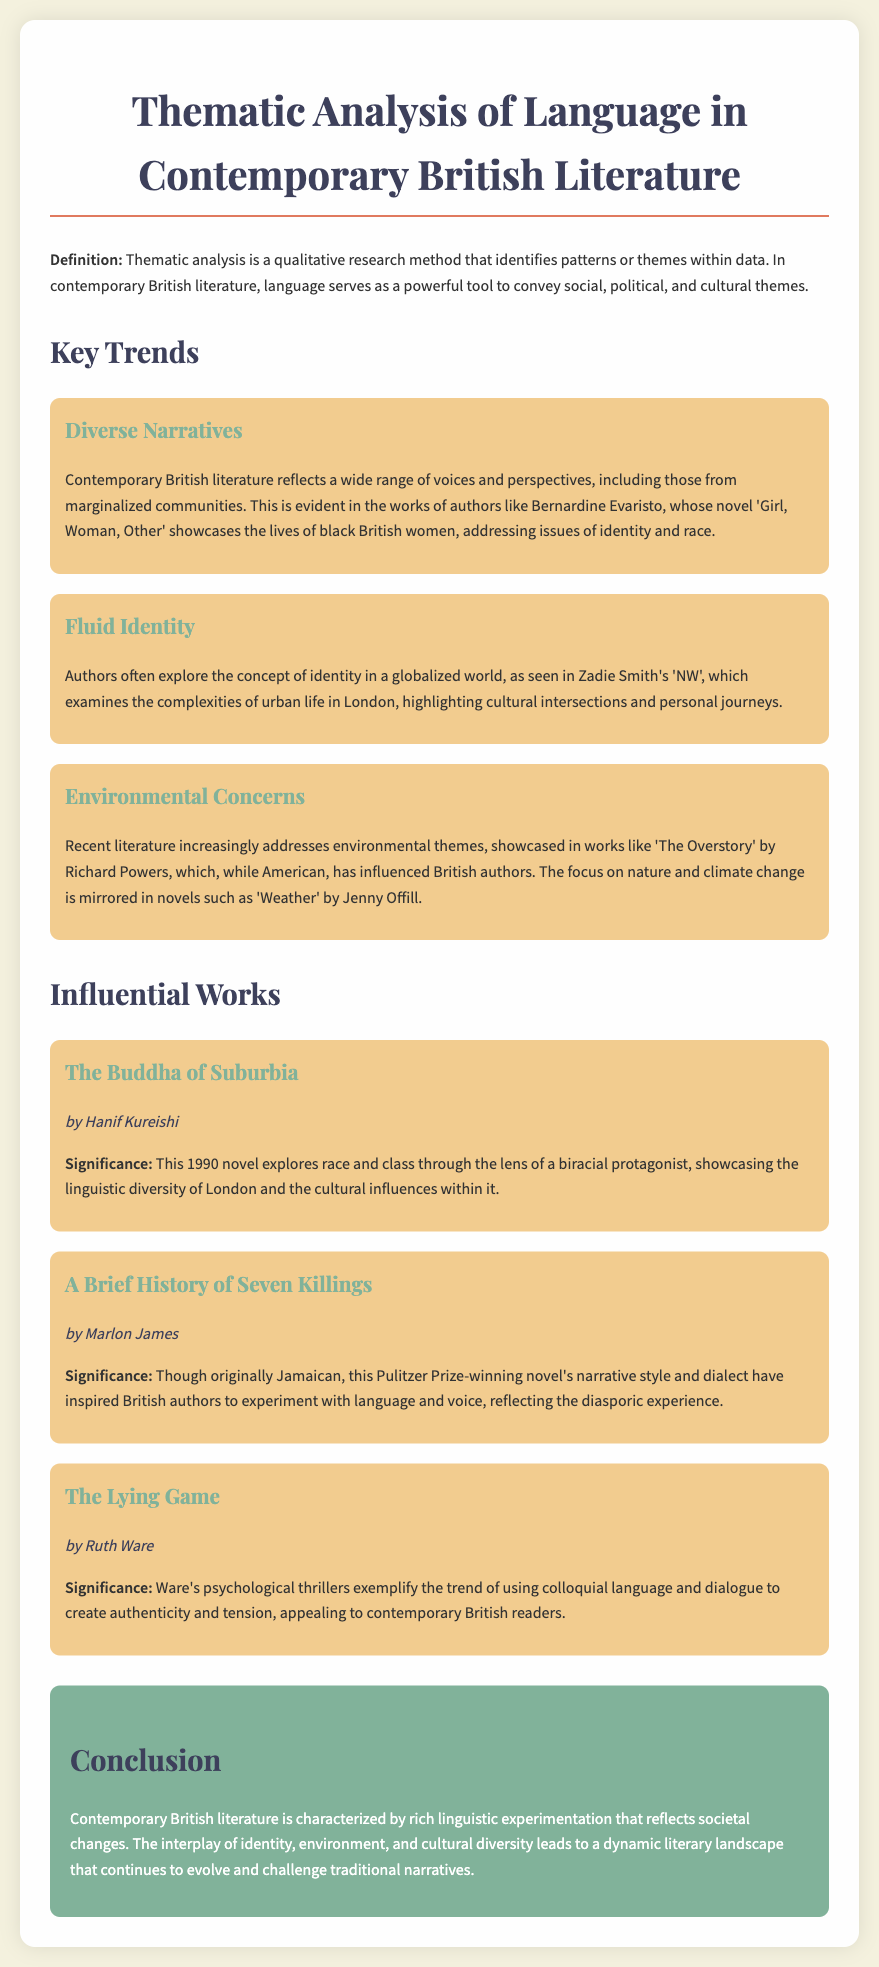What is the primary method used in the thematic analysis? The thematic analysis is identified as a qualitative research method that identifies patterns or themes within data.
Answer: qualitative research Who is the author of 'Girl, Woman, Other'? The note mentions Bernardine Evaristo as the author of 'Girl, Woman, Other'.
Answer: Bernardine Evaristo What concept is explored in Zadie Smith's 'NW'? The work examines the complexities of urban life in London.
Answer: complexities of urban life Which notable environmental theme is mentioned in the document? The document highlights themes surrounding nature and climate change.
Answer: climate change What year was 'The Buddha of Suburbia' published? The publication year of 'The Buddha of Suburbia' is indicated as 1990.
Answer: 1990 What narrative style is noted as influencing British authors in the document? The document discusses the narrative style of Marlon James' novel.
Answer: narrative style In which genre does Ruth Ware's work fall? The note categorizes Ruth Ware's contributions as psychological thrillers.
Answer: psychological thrillers What is the significance of 'A Brief History of Seven Killings'? The significance involves the inspiration it provides to British authors to experiment with language and voice.
Answer: experiment with language and voice What is emphasized as a characteristic of contemporary British literature? The document emphasizes rich linguistic experimentation.
Answer: rich linguistic experimentation 